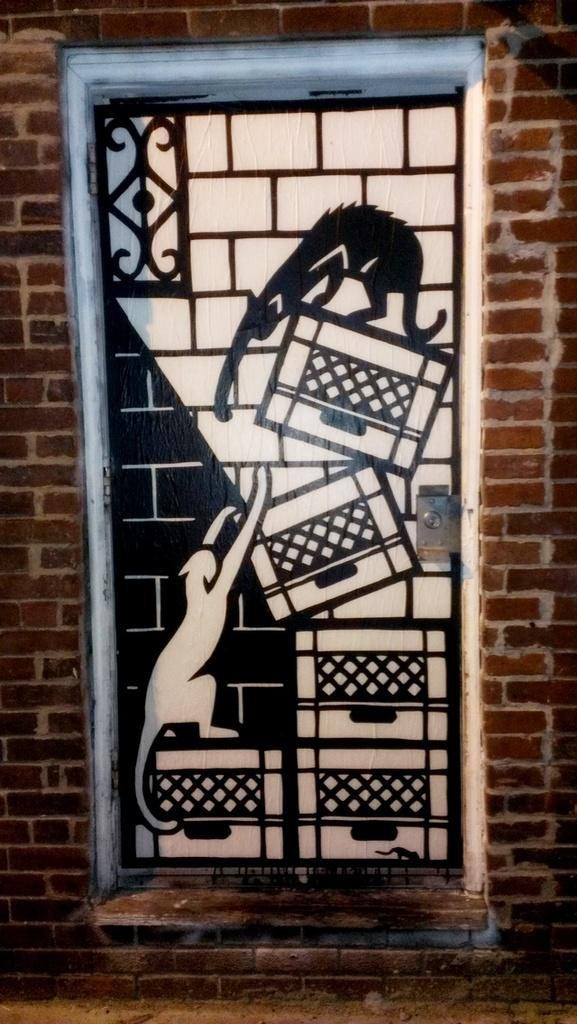What type of structure is visible in the image? There is a brick wall in the image. Can you identify any openings in the brick wall? Yes, there is a door in the image. How many icicles are hanging from the door in the image? There are no icicles present in the image. Is there a spy hiding behind the brick wall in the image? There is no indication of a spy or any hidden figures in the image. 